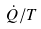<formula> <loc_0><loc_0><loc_500><loc_500>\dot { Q } / T</formula> 